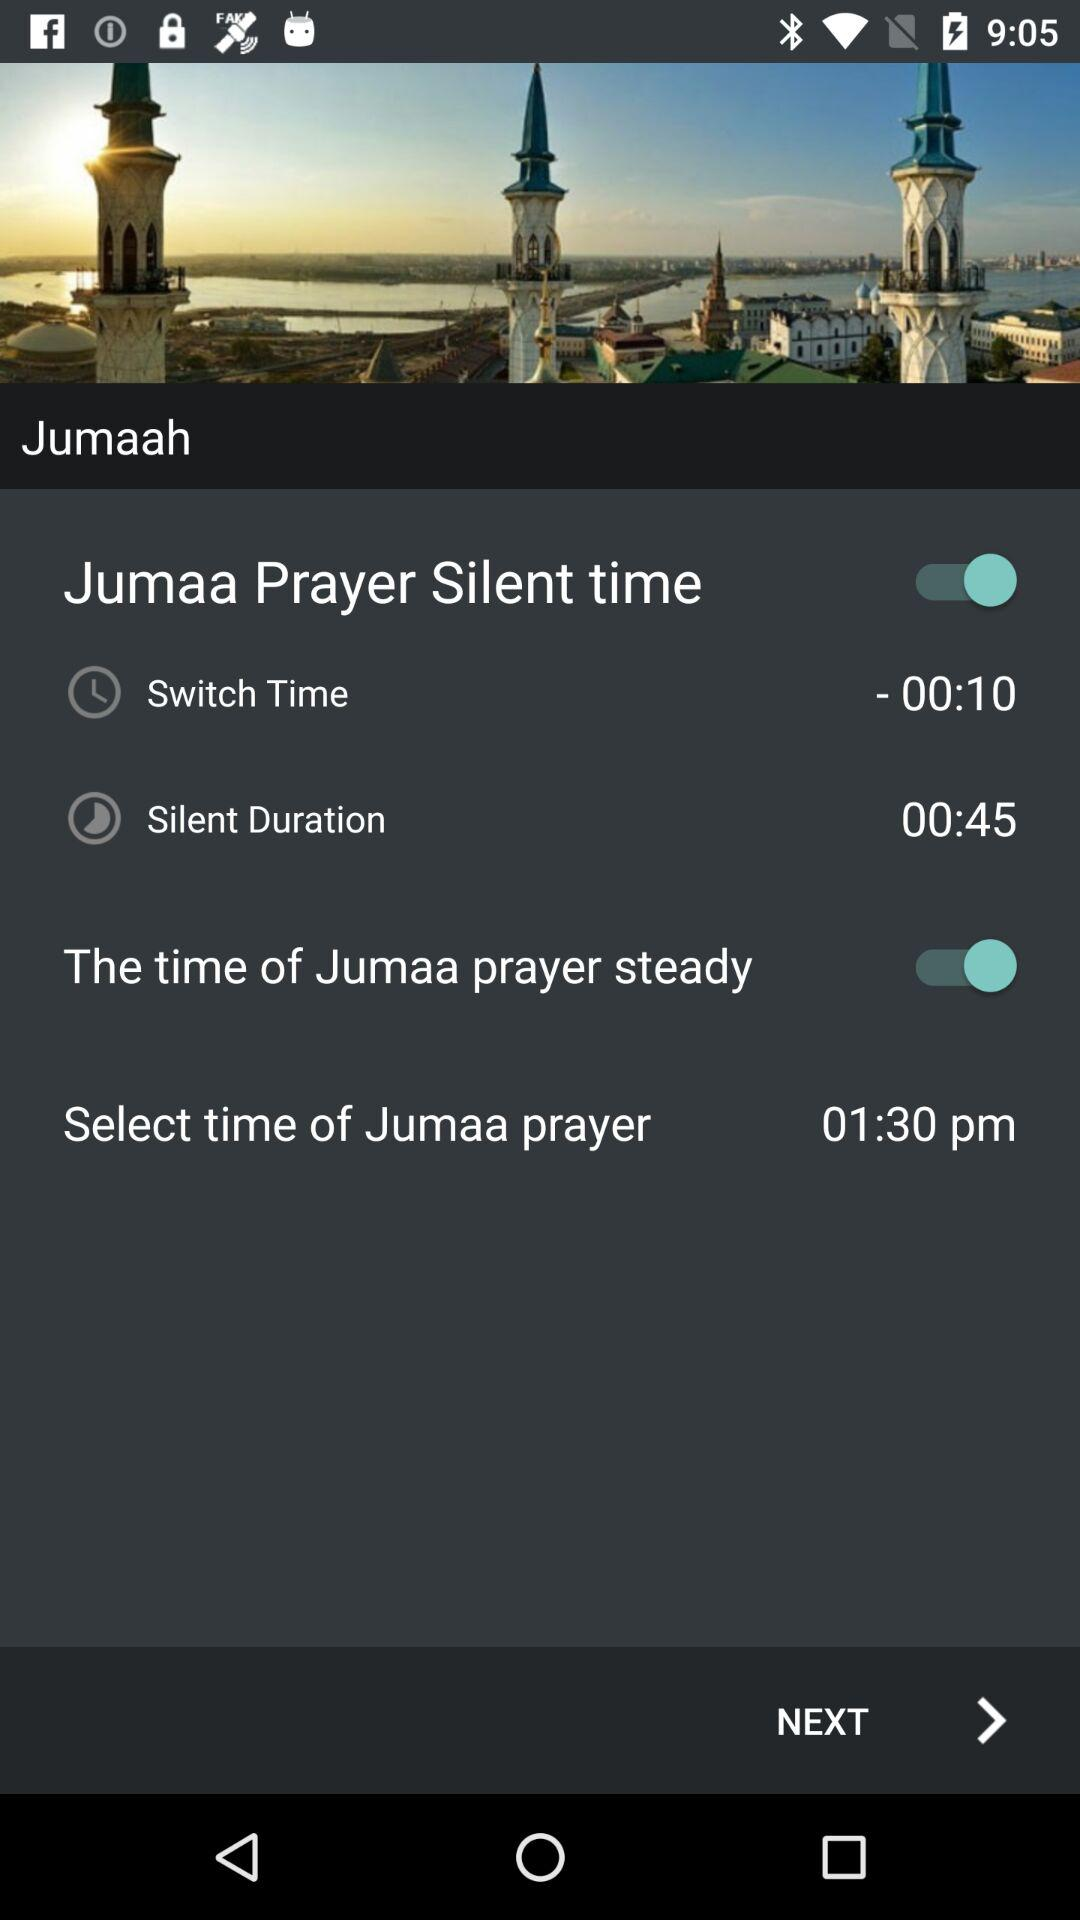Who is this application powered by?
When the provided information is insufficient, respond with <no answer>. <no answer> 